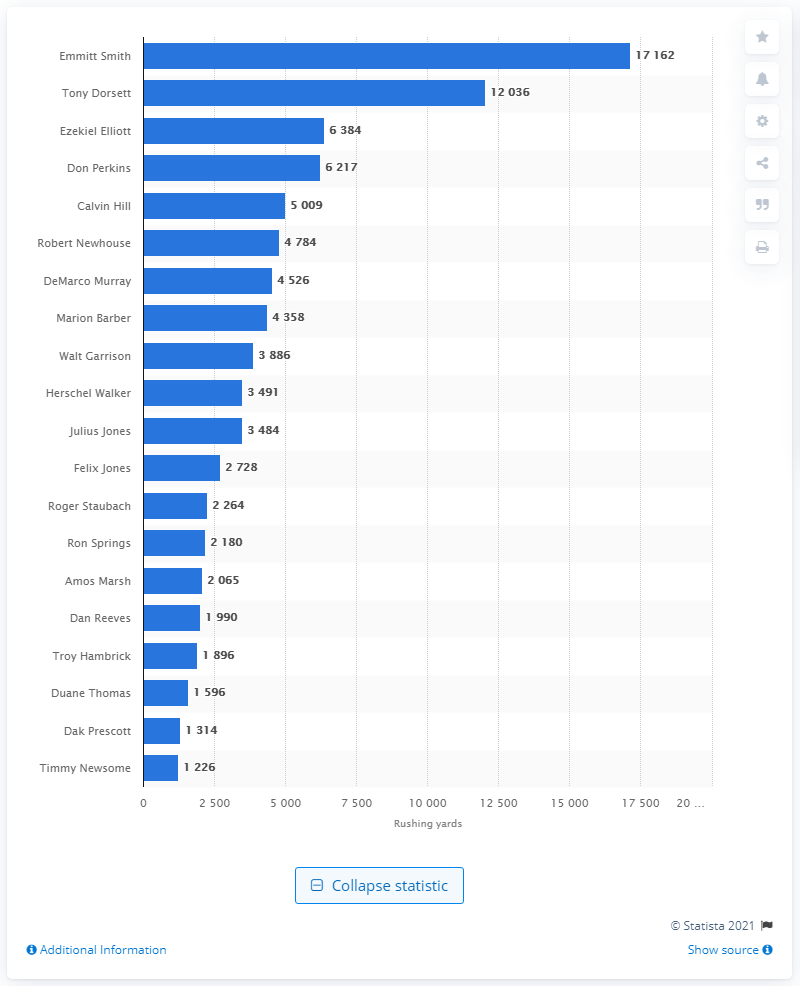List a handful of essential elements in this visual. Emmitt Smith is the career rushing leader of the Dallas Cowboys. 